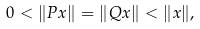Convert formula to latex. <formula><loc_0><loc_0><loc_500><loc_500>0 < \| P x \| = \| Q x \| < \| x \| ,</formula> 